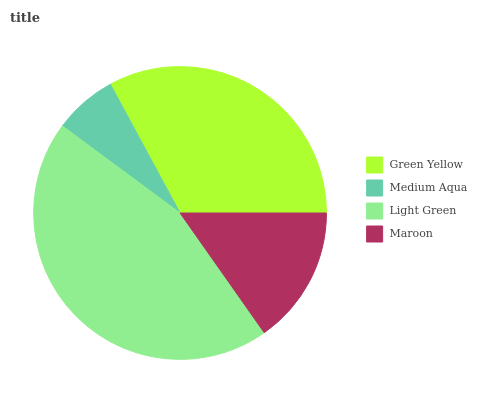Is Medium Aqua the minimum?
Answer yes or no. Yes. Is Light Green the maximum?
Answer yes or no. Yes. Is Light Green the minimum?
Answer yes or no. No. Is Medium Aqua the maximum?
Answer yes or no. No. Is Light Green greater than Medium Aqua?
Answer yes or no. Yes. Is Medium Aqua less than Light Green?
Answer yes or no. Yes. Is Medium Aqua greater than Light Green?
Answer yes or no. No. Is Light Green less than Medium Aqua?
Answer yes or no. No. Is Green Yellow the high median?
Answer yes or no. Yes. Is Maroon the low median?
Answer yes or no. Yes. Is Medium Aqua the high median?
Answer yes or no. No. Is Green Yellow the low median?
Answer yes or no. No. 